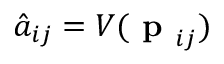<formula> <loc_0><loc_0><loc_500><loc_500>\hat { a } _ { i j } = V ( p _ { i j } )</formula> 